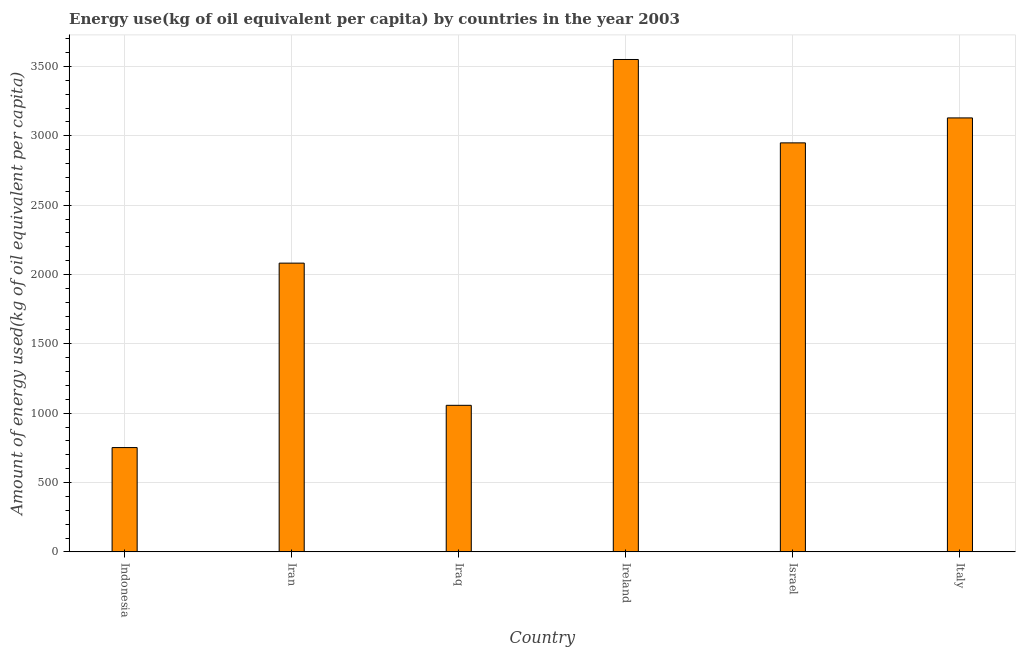Does the graph contain grids?
Your response must be concise. Yes. What is the title of the graph?
Your response must be concise. Energy use(kg of oil equivalent per capita) by countries in the year 2003. What is the label or title of the Y-axis?
Provide a short and direct response. Amount of energy used(kg of oil equivalent per capita). What is the amount of energy used in Iraq?
Give a very brief answer. 1056.8. Across all countries, what is the maximum amount of energy used?
Provide a short and direct response. 3550.46. Across all countries, what is the minimum amount of energy used?
Give a very brief answer. 752.11. In which country was the amount of energy used maximum?
Provide a succinct answer. Ireland. What is the sum of the amount of energy used?
Your answer should be compact. 1.35e+04. What is the difference between the amount of energy used in Ireland and Israel?
Provide a succinct answer. 601.16. What is the average amount of energy used per country?
Ensure brevity in your answer.  2253.31. What is the median amount of energy used?
Your answer should be very brief. 2515.67. What is the ratio of the amount of energy used in Iran to that in Iraq?
Ensure brevity in your answer.  1.97. What is the difference between the highest and the second highest amount of energy used?
Your answer should be very brief. 421.29. Is the sum of the amount of energy used in Iran and Italy greater than the maximum amount of energy used across all countries?
Your answer should be compact. Yes. What is the difference between the highest and the lowest amount of energy used?
Offer a very short reply. 2798.35. How many bars are there?
Give a very brief answer. 6. Are all the bars in the graph horizontal?
Keep it short and to the point. No. What is the difference between two consecutive major ticks on the Y-axis?
Offer a terse response. 500. What is the Amount of energy used(kg of oil equivalent per capita) in Indonesia?
Provide a short and direct response. 752.11. What is the Amount of energy used(kg of oil equivalent per capita) in Iran?
Offer a terse response. 2082.04. What is the Amount of energy used(kg of oil equivalent per capita) of Iraq?
Your response must be concise. 1056.8. What is the Amount of energy used(kg of oil equivalent per capita) of Ireland?
Offer a terse response. 3550.46. What is the Amount of energy used(kg of oil equivalent per capita) in Israel?
Provide a short and direct response. 2949.3. What is the Amount of energy used(kg of oil equivalent per capita) in Italy?
Provide a succinct answer. 3129.16. What is the difference between the Amount of energy used(kg of oil equivalent per capita) in Indonesia and Iran?
Offer a very short reply. -1329.93. What is the difference between the Amount of energy used(kg of oil equivalent per capita) in Indonesia and Iraq?
Provide a short and direct response. -304.69. What is the difference between the Amount of energy used(kg of oil equivalent per capita) in Indonesia and Ireland?
Your answer should be very brief. -2798.35. What is the difference between the Amount of energy used(kg of oil equivalent per capita) in Indonesia and Israel?
Provide a succinct answer. -2197.19. What is the difference between the Amount of energy used(kg of oil equivalent per capita) in Indonesia and Italy?
Your answer should be very brief. -2377.06. What is the difference between the Amount of energy used(kg of oil equivalent per capita) in Iran and Iraq?
Offer a very short reply. 1025.25. What is the difference between the Amount of energy used(kg of oil equivalent per capita) in Iran and Ireland?
Offer a terse response. -1468.42. What is the difference between the Amount of energy used(kg of oil equivalent per capita) in Iran and Israel?
Ensure brevity in your answer.  -867.26. What is the difference between the Amount of energy used(kg of oil equivalent per capita) in Iran and Italy?
Provide a short and direct response. -1047.12. What is the difference between the Amount of energy used(kg of oil equivalent per capita) in Iraq and Ireland?
Give a very brief answer. -2493.66. What is the difference between the Amount of energy used(kg of oil equivalent per capita) in Iraq and Israel?
Offer a terse response. -1892.5. What is the difference between the Amount of energy used(kg of oil equivalent per capita) in Iraq and Italy?
Ensure brevity in your answer.  -2072.37. What is the difference between the Amount of energy used(kg of oil equivalent per capita) in Ireland and Israel?
Offer a very short reply. 601.16. What is the difference between the Amount of energy used(kg of oil equivalent per capita) in Ireland and Italy?
Your answer should be very brief. 421.29. What is the difference between the Amount of energy used(kg of oil equivalent per capita) in Israel and Italy?
Ensure brevity in your answer.  -179.86. What is the ratio of the Amount of energy used(kg of oil equivalent per capita) in Indonesia to that in Iran?
Provide a succinct answer. 0.36. What is the ratio of the Amount of energy used(kg of oil equivalent per capita) in Indonesia to that in Iraq?
Provide a short and direct response. 0.71. What is the ratio of the Amount of energy used(kg of oil equivalent per capita) in Indonesia to that in Ireland?
Offer a terse response. 0.21. What is the ratio of the Amount of energy used(kg of oil equivalent per capita) in Indonesia to that in Israel?
Keep it short and to the point. 0.26. What is the ratio of the Amount of energy used(kg of oil equivalent per capita) in Indonesia to that in Italy?
Your answer should be compact. 0.24. What is the ratio of the Amount of energy used(kg of oil equivalent per capita) in Iran to that in Iraq?
Offer a terse response. 1.97. What is the ratio of the Amount of energy used(kg of oil equivalent per capita) in Iran to that in Ireland?
Provide a succinct answer. 0.59. What is the ratio of the Amount of energy used(kg of oil equivalent per capita) in Iran to that in Israel?
Keep it short and to the point. 0.71. What is the ratio of the Amount of energy used(kg of oil equivalent per capita) in Iran to that in Italy?
Keep it short and to the point. 0.67. What is the ratio of the Amount of energy used(kg of oil equivalent per capita) in Iraq to that in Ireland?
Your answer should be very brief. 0.3. What is the ratio of the Amount of energy used(kg of oil equivalent per capita) in Iraq to that in Israel?
Offer a terse response. 0.36. What is the ratio of the Amount of energy used(kg of oil equivalent per capita) in Iraq to that in Italy?
Give a very brief answer. 0.34. What is the ratio of the Amount of energy used(kg of oil equivalent per capita) in Ireland to that in Israel?
Give a very brief answer. 1.2. What is the ratio of the Amount of energy used(kg of oil equivalent per capita) in Ireland to that in Italy?
Offer a very short reply. 1.14. What is the ratio of the Amount of energy used(kg of oil equivalent per capita) in Israel to that in Italy?
Provide a short and direct response. 0.94. 